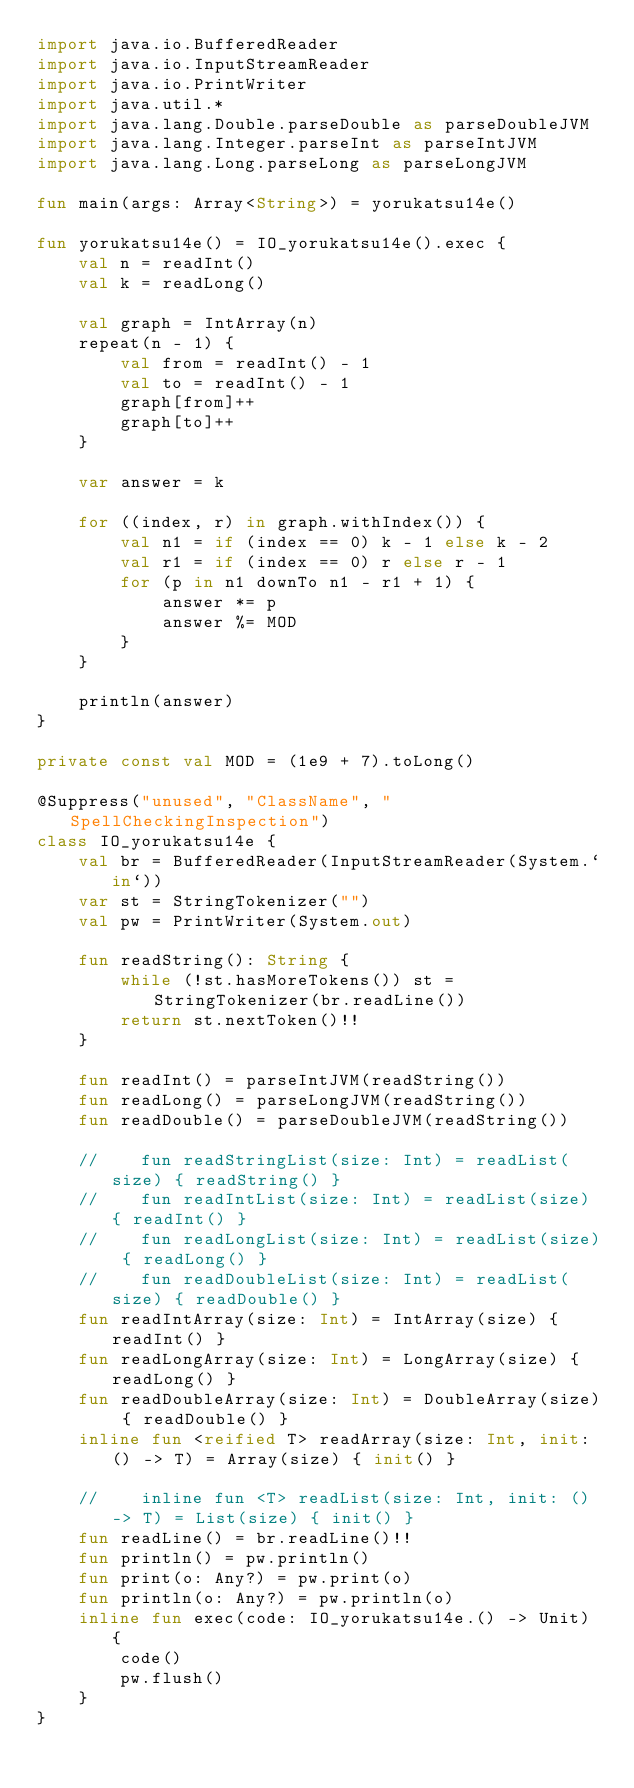<code> <loc_0><loc_0><loc_500><loc_500><_Kotlin_>import java.io.BufferedReader
import java.io.InputStreamReader
import java.io.PrintWriter
import java.util.*
import java.lang.Double.parseDouble as parseDoubleJVM
import java.lang.Integer.parseInt as parseIntJVM
import java.lang.Long.parseLong as parseLongJVM

fun main(args: Array<String>) = yorukatsu14e()

fun yorukatsu14e() = IO_yorukatsu14e().exec {
    val n = readInt()
    val k = readLong()

    val graph = IntArray(n)
    repeat(n - 1) {
        val from = readInt() - 1
        val to = readInt() - 1
        graph[from]++
        graph[to]++
    }

    var answer = k

    for ((index, r) in graph.withIndex()) {
        val n1 = if (index == 0) k - 1 else k - 2
        val r1 = if (index == 0) r else r - 1
        for (p in n1 downTo n1 - r1 + 1) {
            answer *= p
            answer %= MOD
        }
    }

    println(answer)
}

private const val MOD = (1e9 + 7).toLong()

@Suppress("unused", "ClassName", "SpellCheckingInspection")
class IO_yorukatsu14e {
    val br = BufferedReader(InputStreamReader(System.`in`))
    var st = StringTokenizer("")
    val pw = PrintWriter(System.out)

    fun readString(): String {
        while (!st.hasMoreTokens()) st = StringTokenizer(br.readLine())
        return st.nextToken()!!
    }

    fun readInt() = parseIntJVM(readString())
    fun readLong() = parseLongJVM(readString())
    fun readDouble() = parseDoubleJVM(readString())

    //    fun readStringList(size: Int) = readList(size) { readString() }
    //    fun readIntList(size: Int) = readList(size) { readInt() }
    //    fun readLongList(size: Int) = readList(size) { readLong() }
    //    fun readDoubleList(size: Int) = readList(size) { readDouble() }
    fun readIntArray(size: Int) = IntArray(size) { readInt() }
    fun readLongArray(size: Int) = LongArray(size) { readLong() }
    fun readDoubleArray(size: Int) = DoubleArray(size) { readDouble() }
    inline fun <reified T> readArray(size: Int, init: () -> T) = Array(size) { init() }

    //    inline fun <T> readList(size: Int, init: () -> T) = List(size) { init() }
    fun readLine() = br.readLine()!!
    fun println() = pw.println()
    fun print(o: Any?) = pw.print(o)
    fun println(o: Any?) = pw.println(o)
    inline fun exec(code: IO_yorukatsu14e.() -> Unit) {
        code()
        pw.flush()
    }
}
</code> 